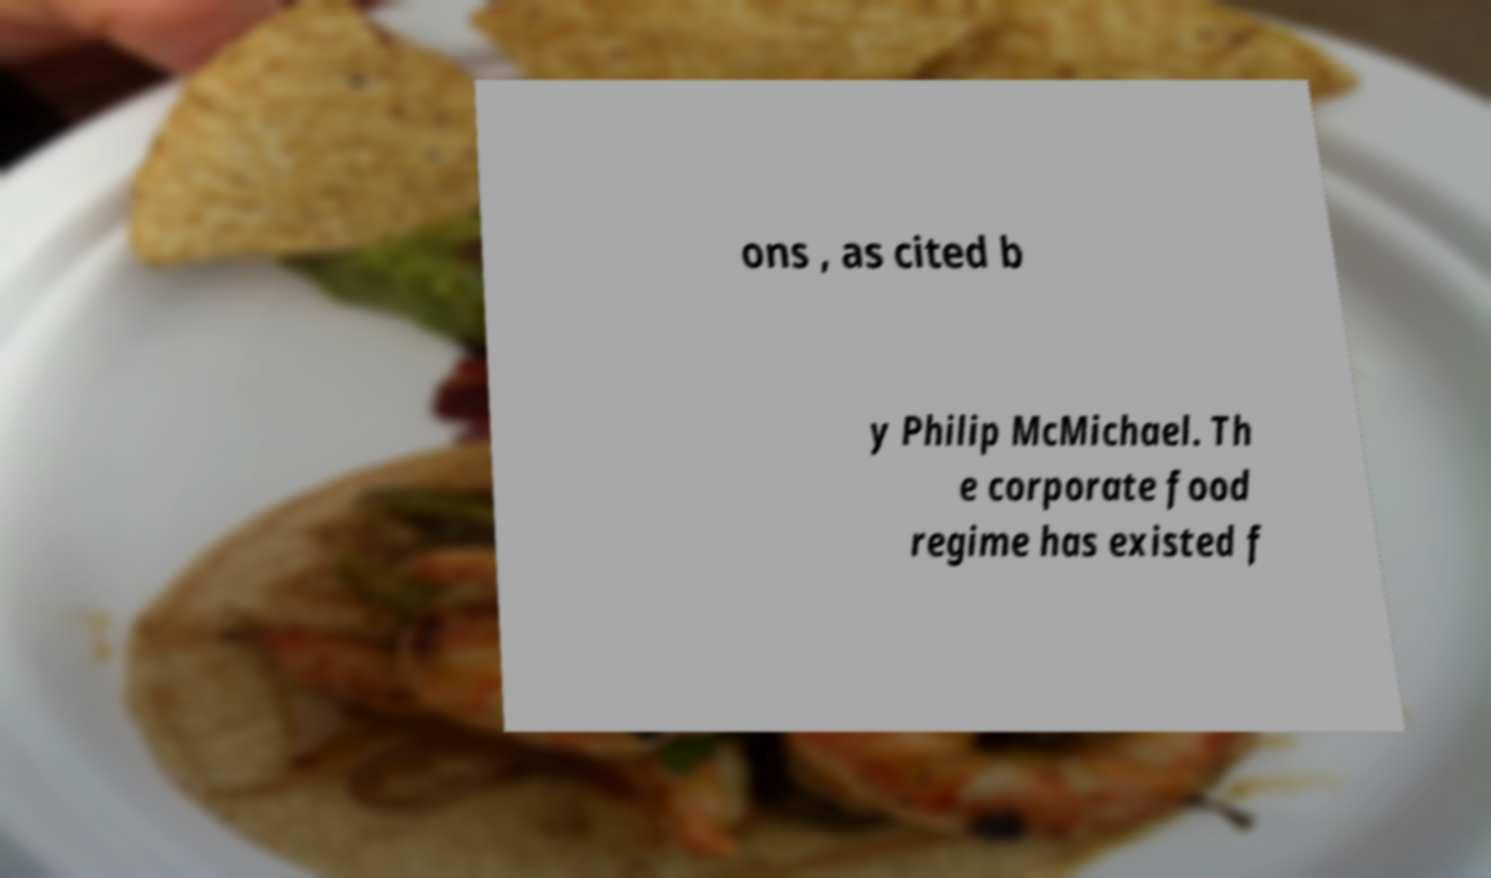I need the written content from this picture converted into text. Can you do that? ons , as cited b y Philip McMichael. Th e corporate food regime has existed f 